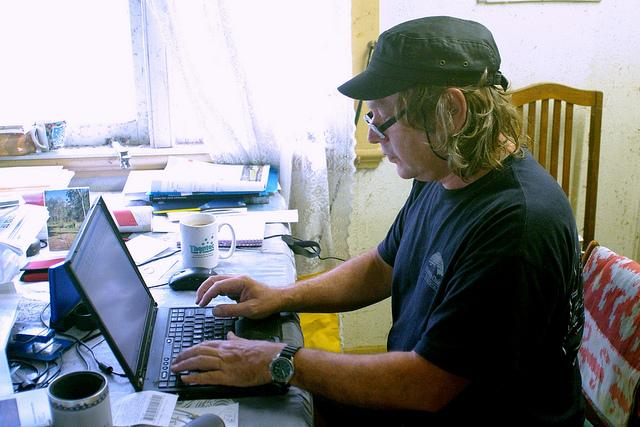Approximately what time is it?

Choices:
A) 925
B) 155
C) 1205
D) 255 255 